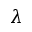<formula> <loc_0><loc_0><loc_500><loc_500>\lambda</formula> 